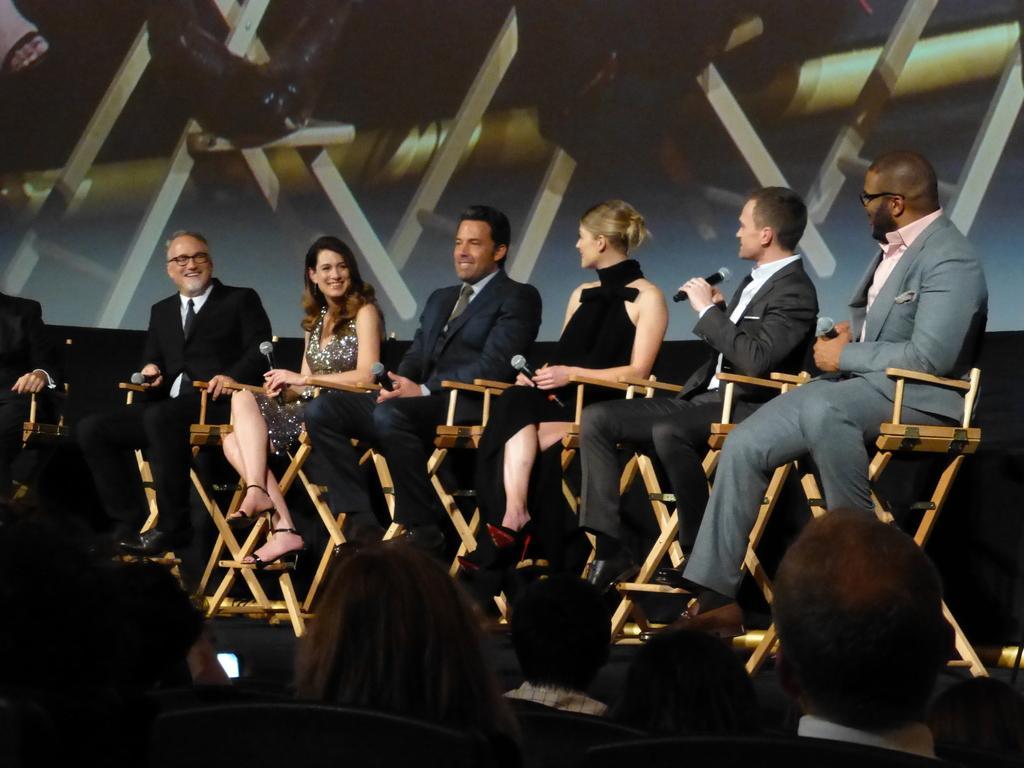Could you give a brief overview of what you see in this image? In this image I can see number of people are sitting on chairs and I can see all of them are wearing formal dress. I can also see all of them are holding mics and In the background I can see a screen. 